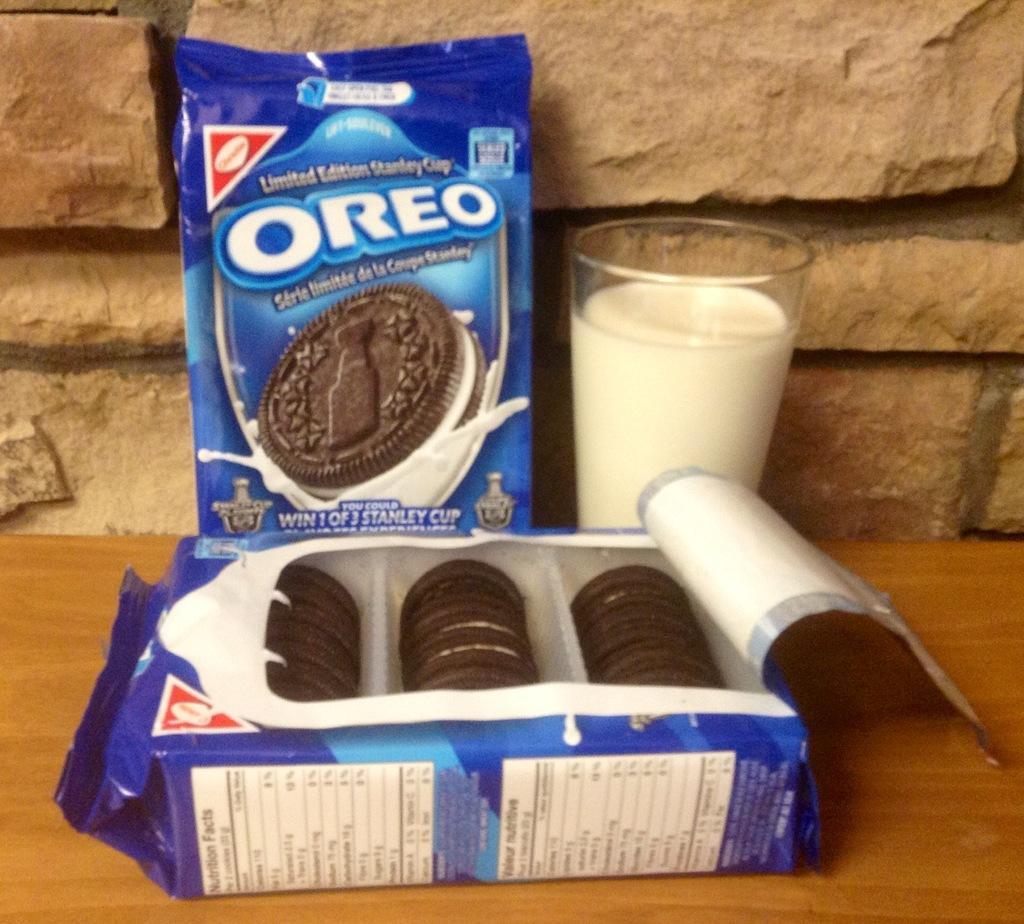In one or two sentences, can you explain what this image depicts? In this picture we can see packets and glass with milk on the table. In the background of the image we can see wall. 